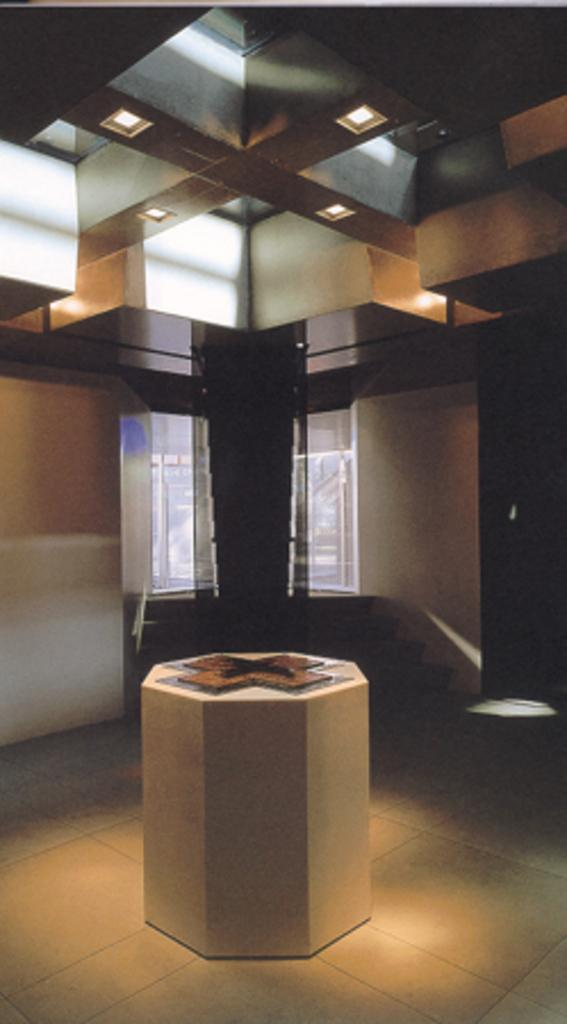What is the small structure in the image? There is a small pillar in the image. What type of material is used for the windows in the image? There are glass windows in the image. What disease is being treated by the unit in the image? There is no unit or disease present in the image; it only features a small pillar and glass windows. What is the desire of the person in the image? There is no person present in the image, so it is impossible to determine their desires. 